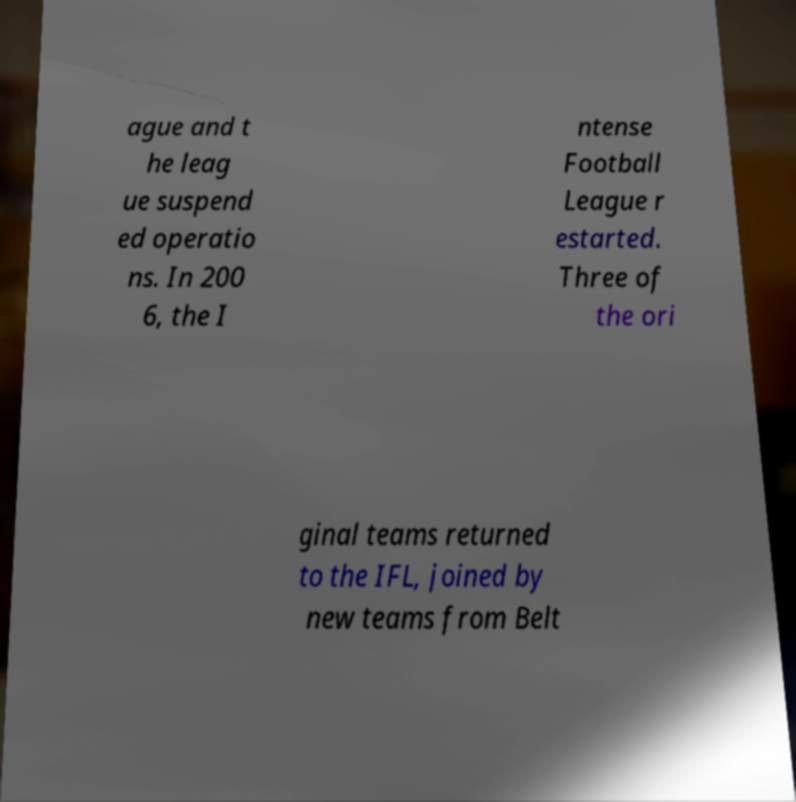For documentation purposes, I need the text within this image transcribed. Could you provide that? ague and t he leag ue suspend ed operatio ns. In 200 6, the I ntense Football League r estarted. Three of the ori ginal teams returned to the IFL, joined by new teams from Belt 